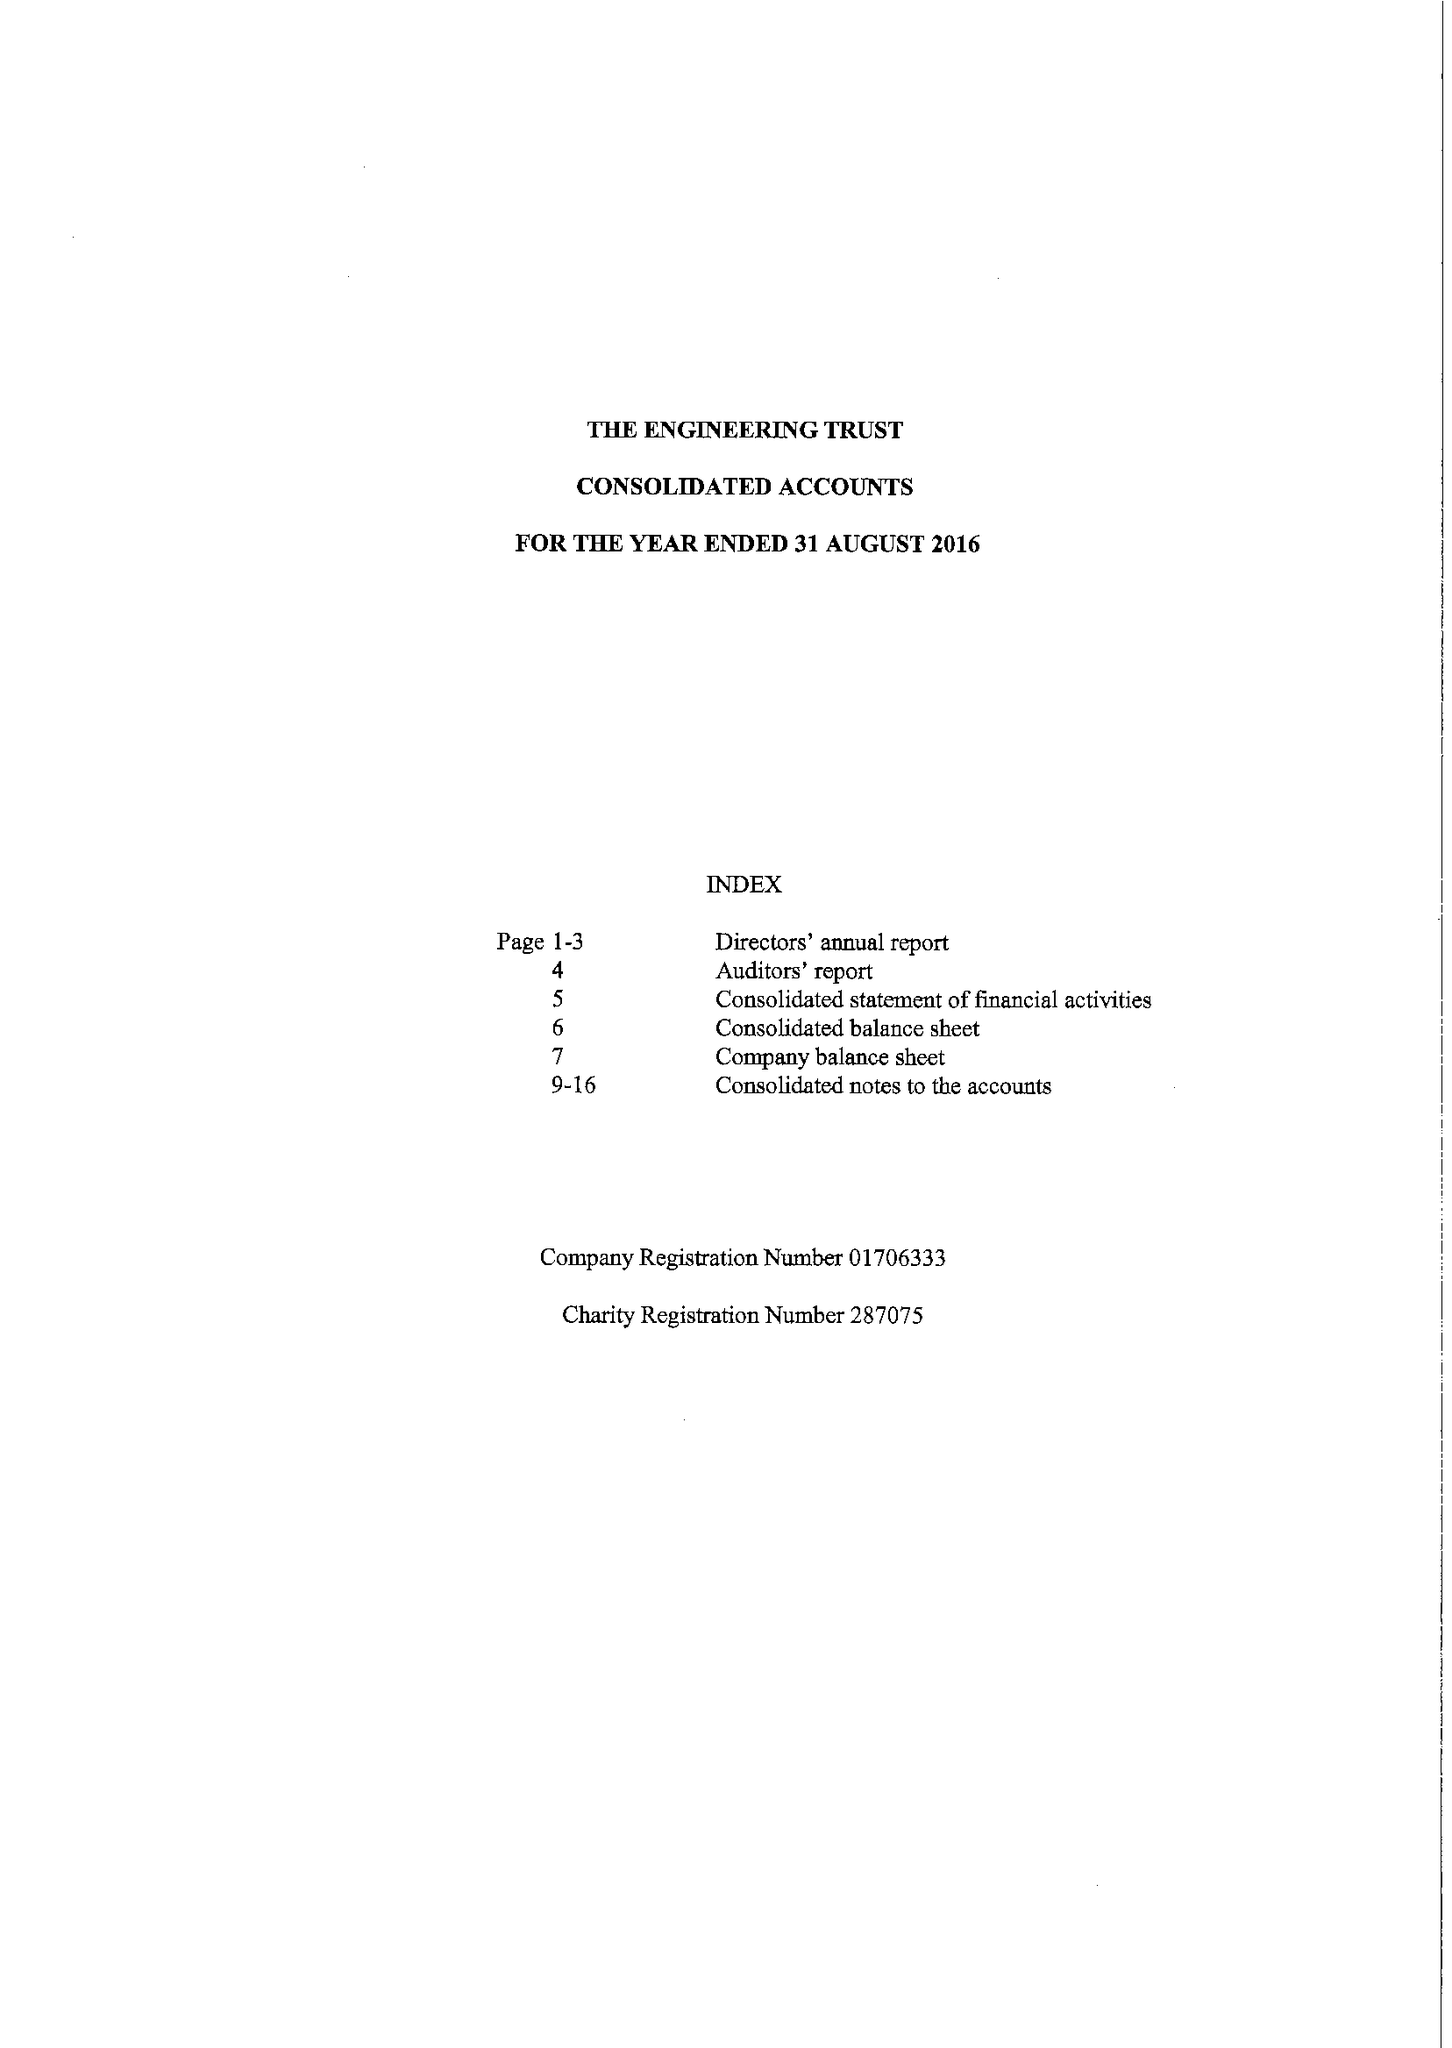What is the value for the address__postcode?
Answer the question using a single word or phrase. OX27 8TG 